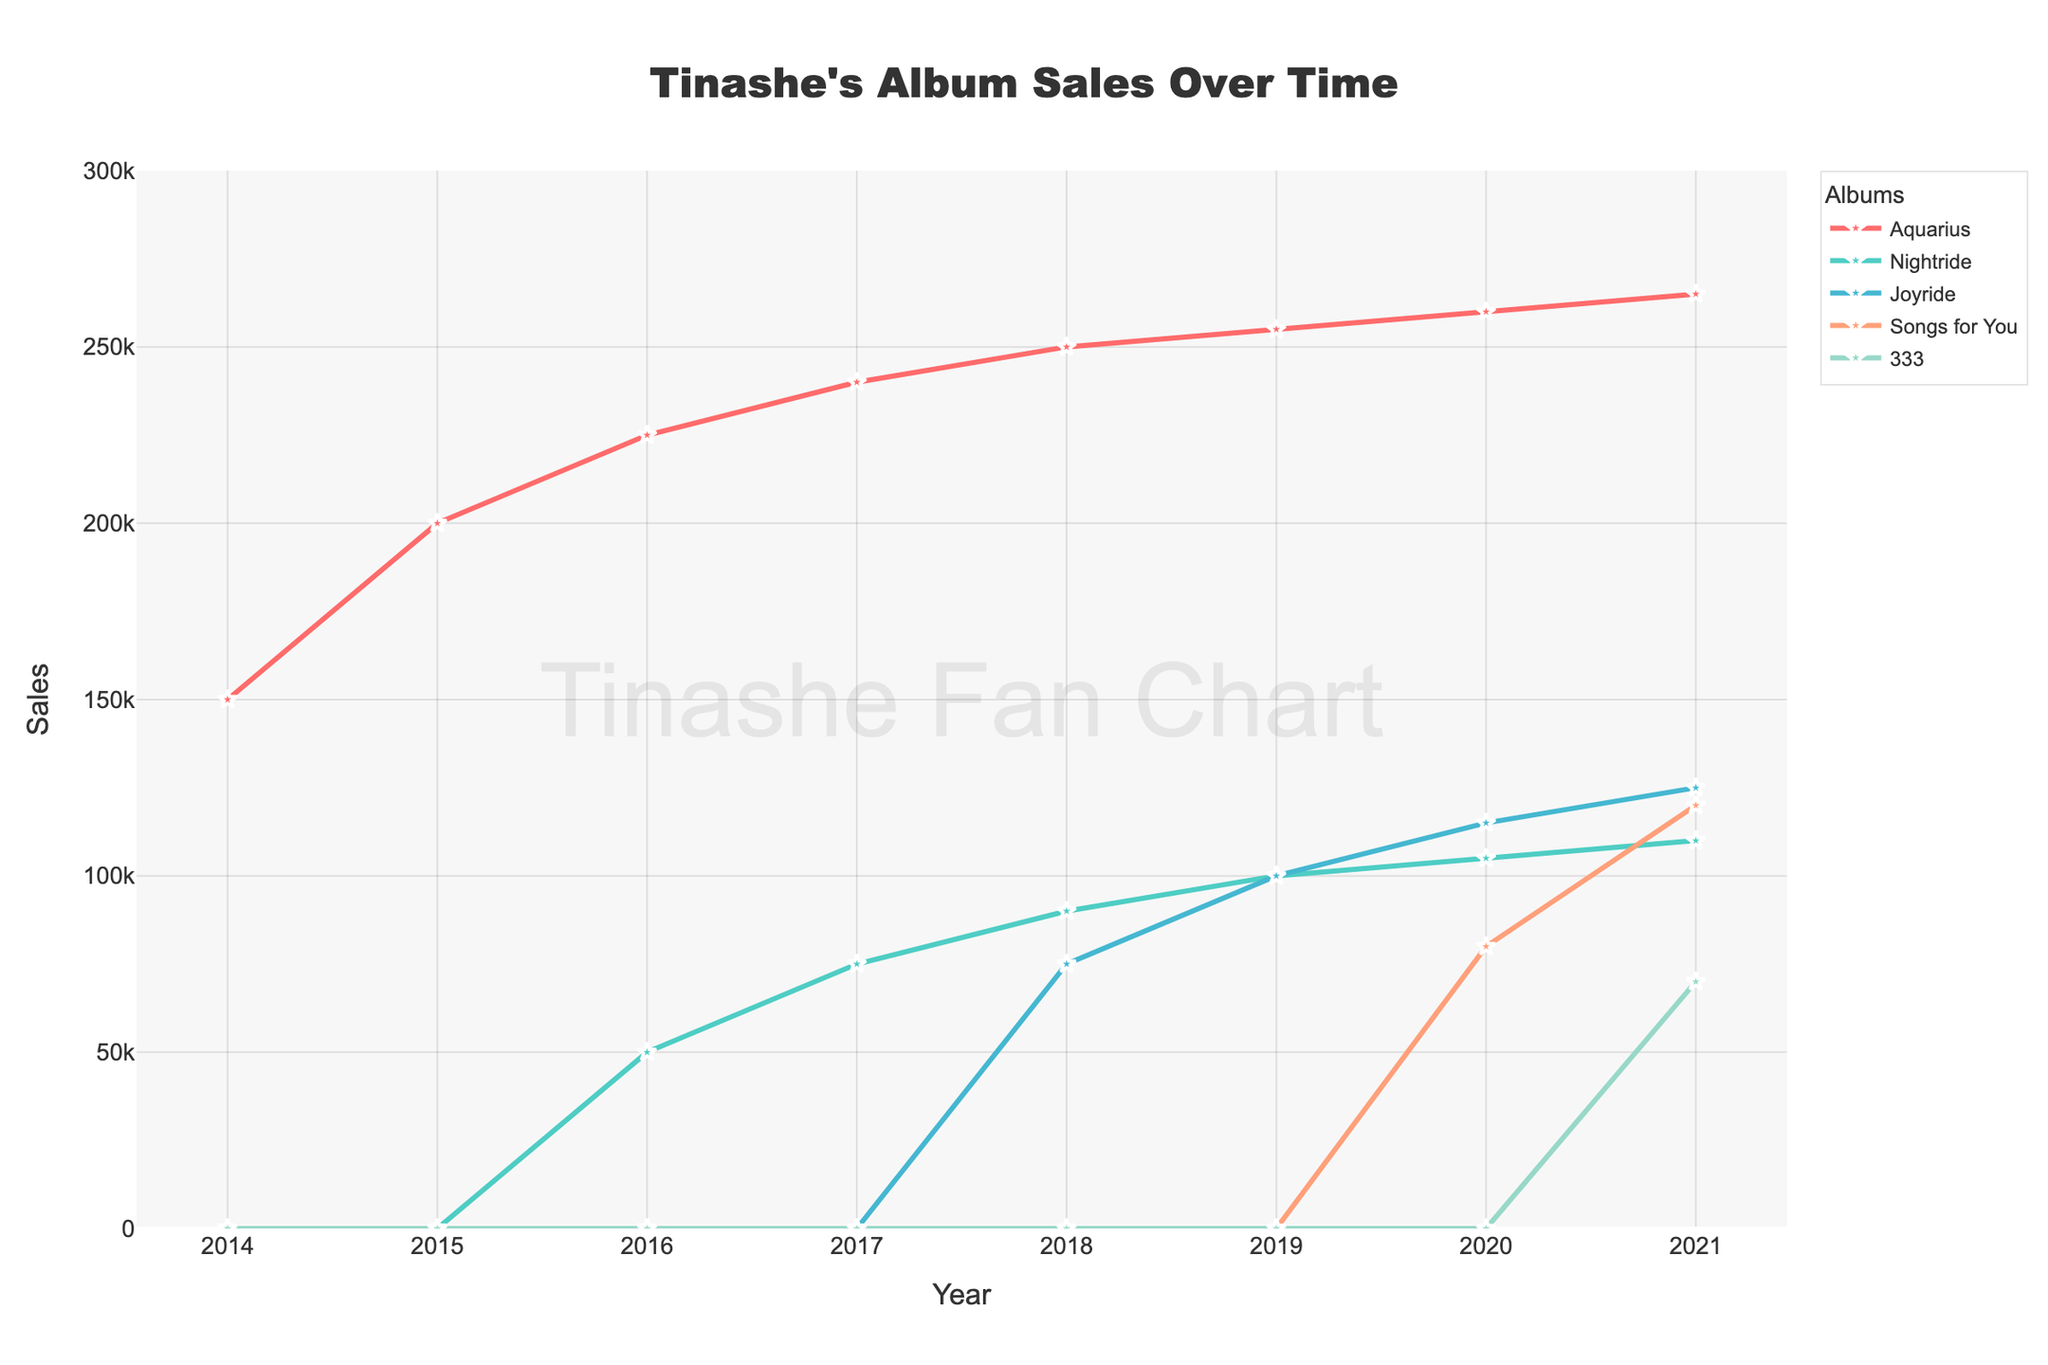Which album had the highest sales in 2021? By looking at the plot for the year 2021, we see that "Songs for You" has the tallest marker, indicating it had the highest sales.
Answer: Songs for You What is the difference in sales between "Aquarius" and "Nightride" in 2017? The sales of "Aquarius" in 2017 are 240,000, and the sales of "Nightride" are 75,000. The difference is 240,000 - 75,000 = 165,000.
Answer: 165,000 How did the sales of "Joyride" change between 2018 and 2019? The sales of "Joyride" in 2018 were 75,000 and in 2019 they were 100,000. The increase in sales is 100,000 - 75,000 = 25,000.
Answer: Increased by 25,000 Which album had no sales until 2020? By observing when each album starts to show sale markers, we see "Songs for You" had no sales until 2020 while others had earlier sales.
Answer: Songs for You Which album's sales saw the smallest increase from year to year? Observing the line plots, "Aquarius" shows the smallest incremental increases each year compared to the others.
Answer: Aquarius In which year did "Nightride" surpass 100,000 in sales? "Nightride" surpasses 100,000 in sales in the year 2020, as indicated by the plot.
Answer: 2020 What is the total combined sales for "Songs for You" over 2020 and 2021? "Songs for You" sold 80,000 in 2020 and 120,000 in 2021. Summing these, 80,000 + 120,000 = 200,000.
Answer: 200,000 Which album had the least growth from 2019 to 2021? Observing the slopes of the lines from 2019 to 2021, "Nightride" shows the least growth with minimal increase over these years.
Answer: Nightride How many albums showed sales in the year 2016? Viewing the plot for the year 2016, only "Aquarius" and "Nightride" have sales.
Answer: Two albums 